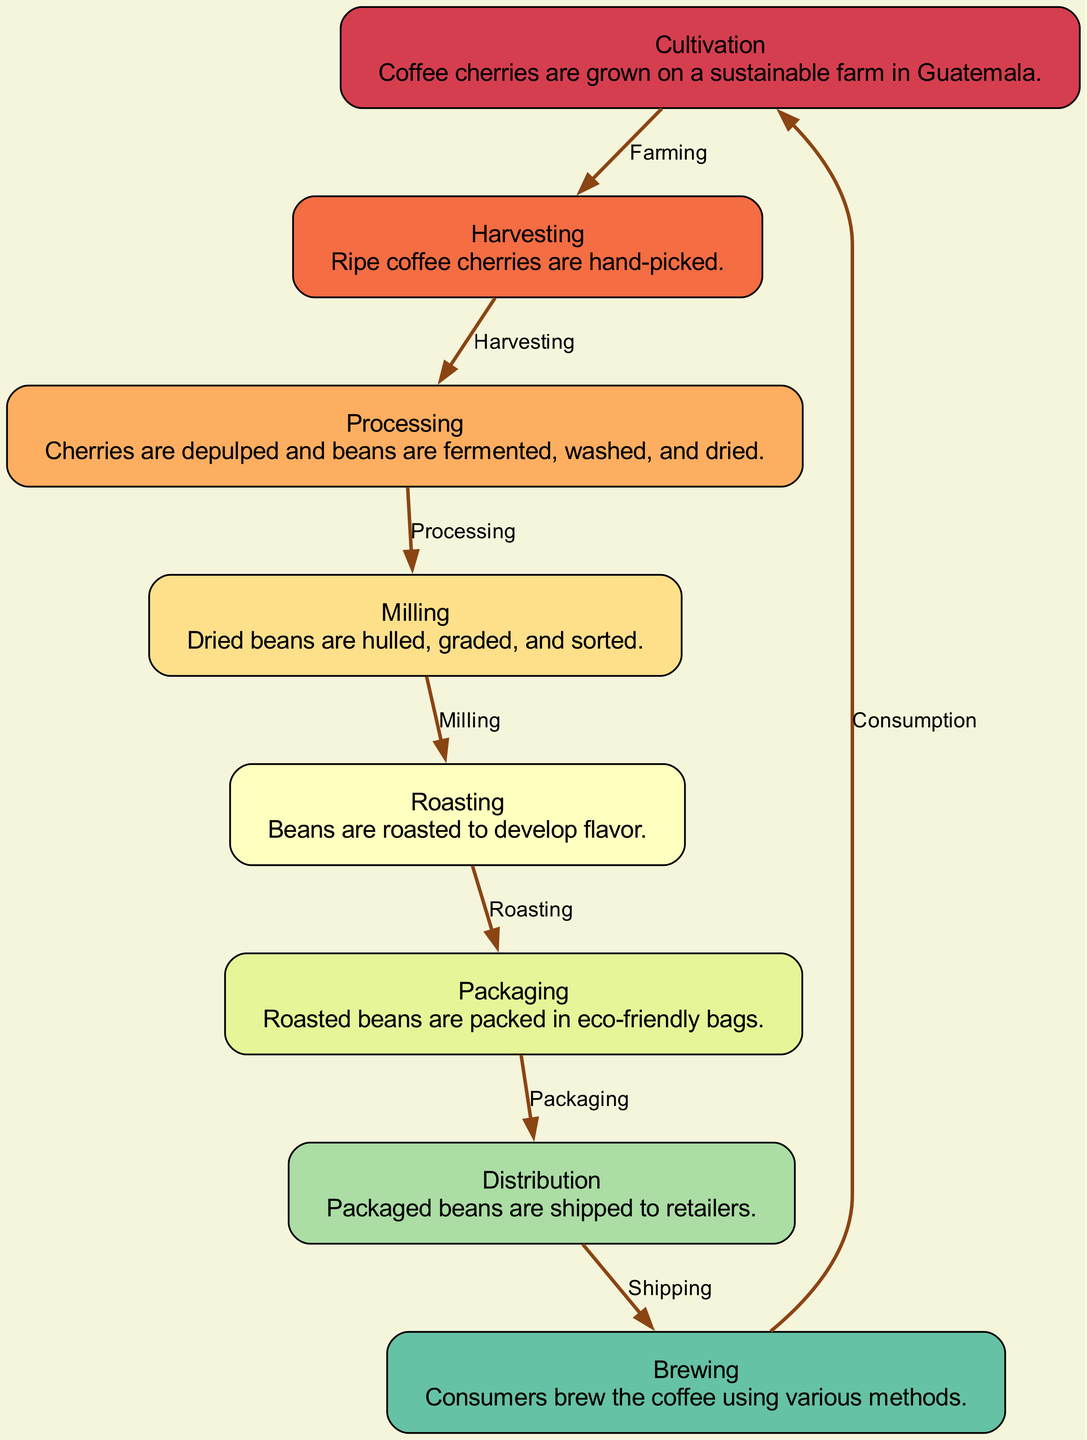What is the first step in the coffee journey? The diagram starts with the "Cultivation" step, indicating it's the initial phase where coffee cherries are grown on the sustainable farm.
Answer: Cultivation How many total steps are there from cultivation to brewing? By counting the nodes in the diagram, there are a total of eight steps listed, from "Cultivation" to "Brewing."
Answer: Eight What is the relationship between "Harvesting" and "Processing"? The edge connecting "Harvesting" to "Processing" clearly indicates that harvesting is followed by the processing of the coffee cherries.
Answer: Processing Which step involves removing the outer layers of the beans? The "Milling" step specifically includes the hulling process where dried beans have their outer layers removed.
Answer: Milling What are the interaction labels between "Brewing" and "Consumption"? The diagram indicates that the relationship between "Brewing" and "Consumption" is marked as "Consumption," suggesting that brewed coffee leads to its consumption.
Answer: Consumption What is the primary purpose of the "Roasting" step? The diagram describes that "Roasting" is intended to develop the flavor of the coffee beans, defining its critical role in enhancing taste.
Answer: Develop flavor In which step are beans packed into eco-friendly bags? The "Packaging" step specifies that the roasted beans are packed in eco-friendly bags to promote sustainability.
Answer: Packaging What part of the journey do consumers directly engage with? The "Brewing" step is where consumers directly engage by brewing the coffee through various methods.
Answer: Brewing Which step follows “Milling” in the coffee production process? Based on the flow of the diagram, "Milling" is followed by "Roasting," establishing the sequential order between the two processes.
Answer: Roasting 